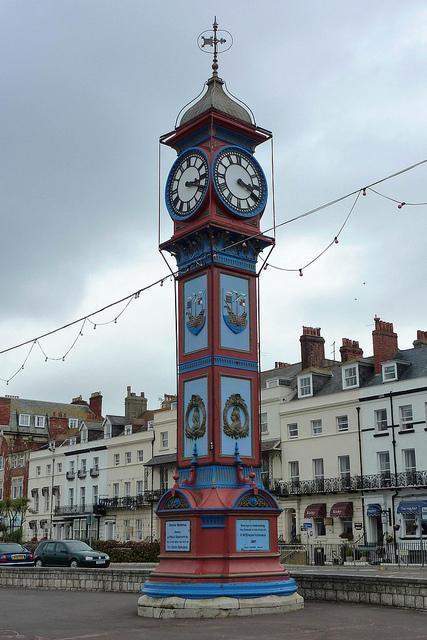How many clocks are there?
Give a very brief answer. 2. How many elephants are near the rocks?
Give a very brief answer. 0. 